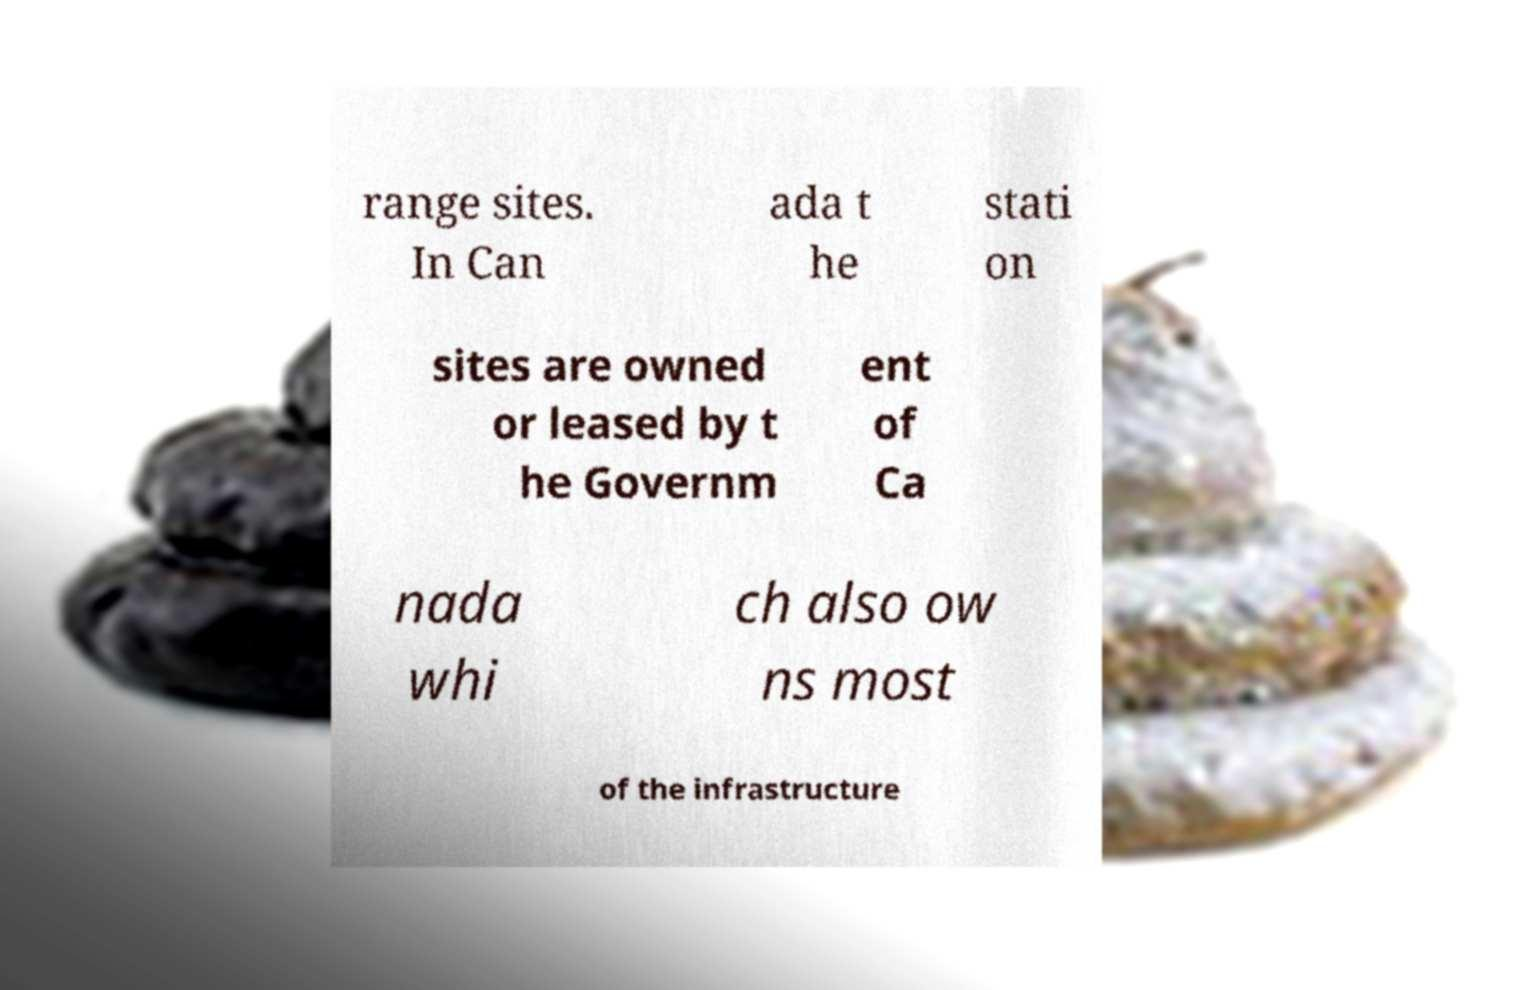Please read and relay the text visible in this image. What does it say? range sites. In Can ada t he stati on sites are owned or leased by t he Governm ent of Ca nada whi ch also ow ns most of the infrastructure 